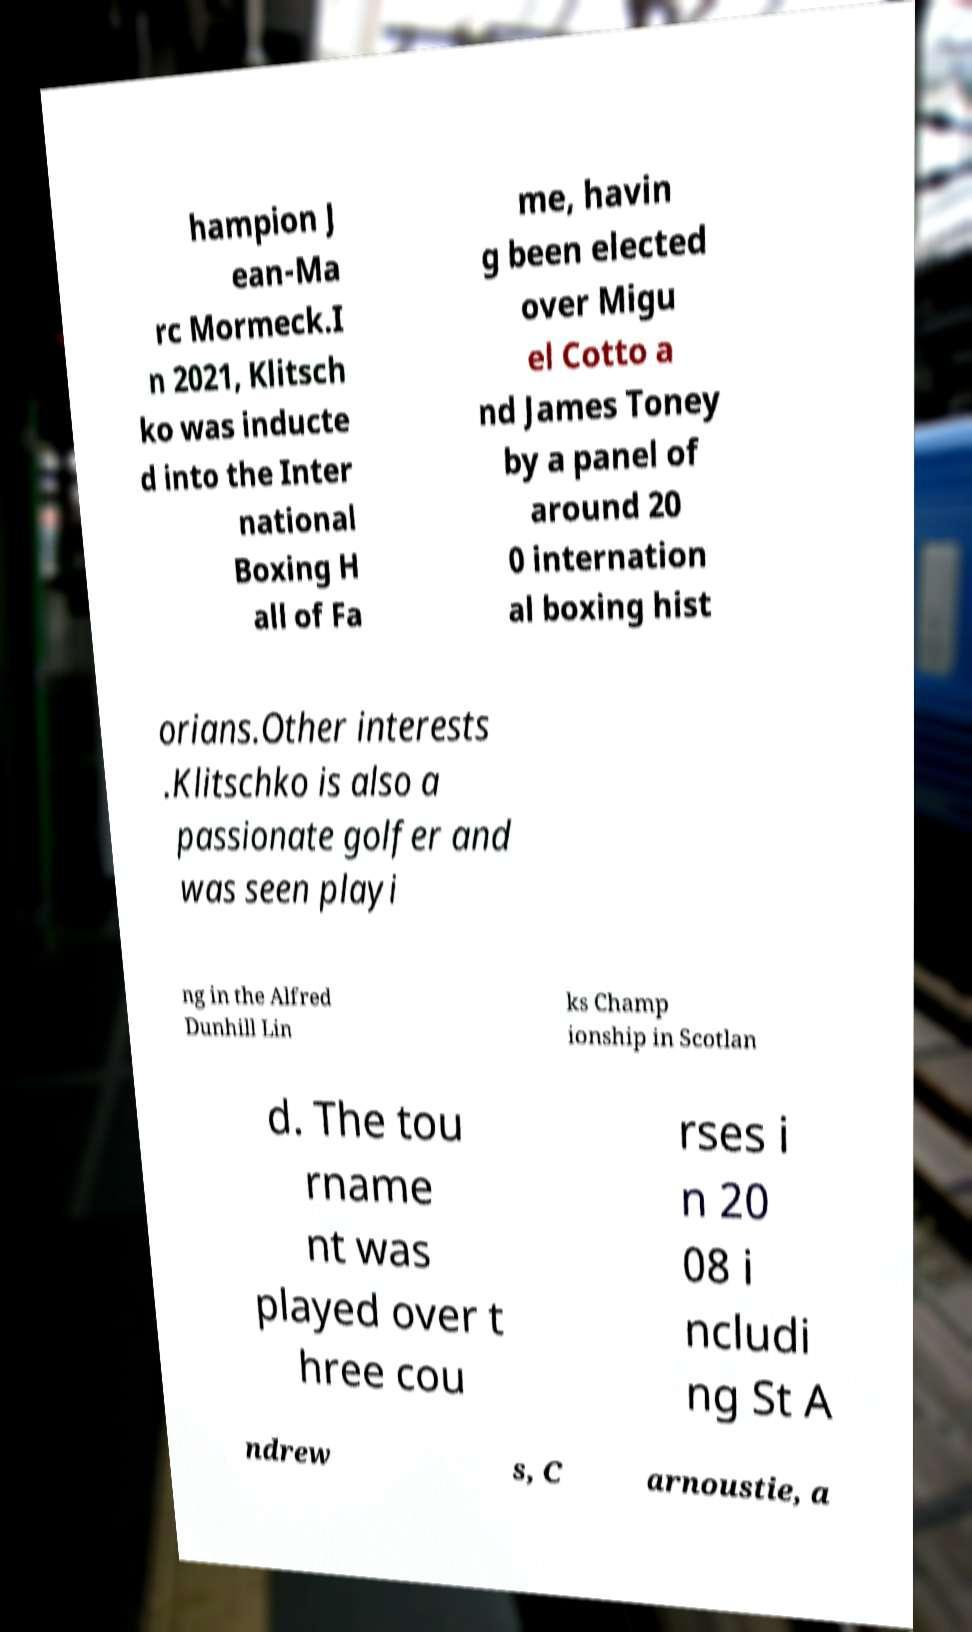For documentation purposes, I need the text within this image transcribed. Could you provide that? hampion J ean-Ma rc Mormeck.I n 2021, Klitsch ko was inducte d into the Inter national Boxing H all of Fa me, havin g been elected over Migu el Cotto a nd James Toney by a panel of around 20 0 internation al boxing hist orians.Other interests .Klitschko is also a passionate golfer and was seen playi ng in the Alfred Dunhill Lin ks Champ ionship in Scotlan d. The tou rname nt was played over t hree cou rses i n 20 08 i ncludi ng St A ndrew s, C arnoustie, a 